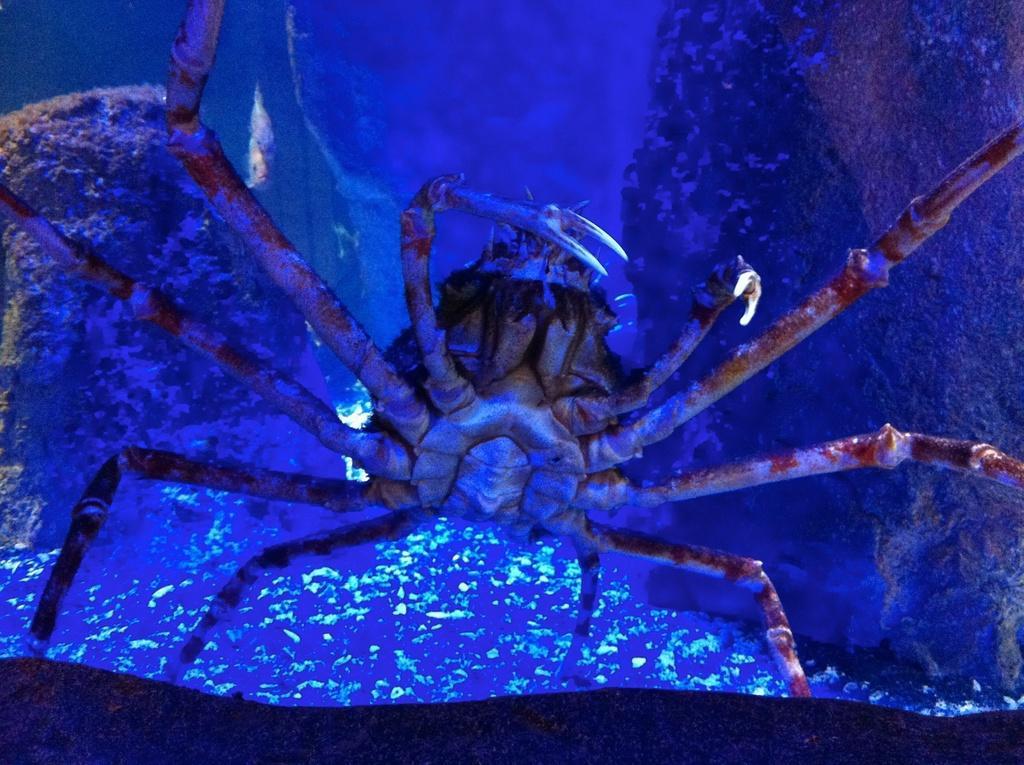Describe this image in one or two sentences. In this image, we can see an insect. There is a rock on the left and on the right side of the image. 